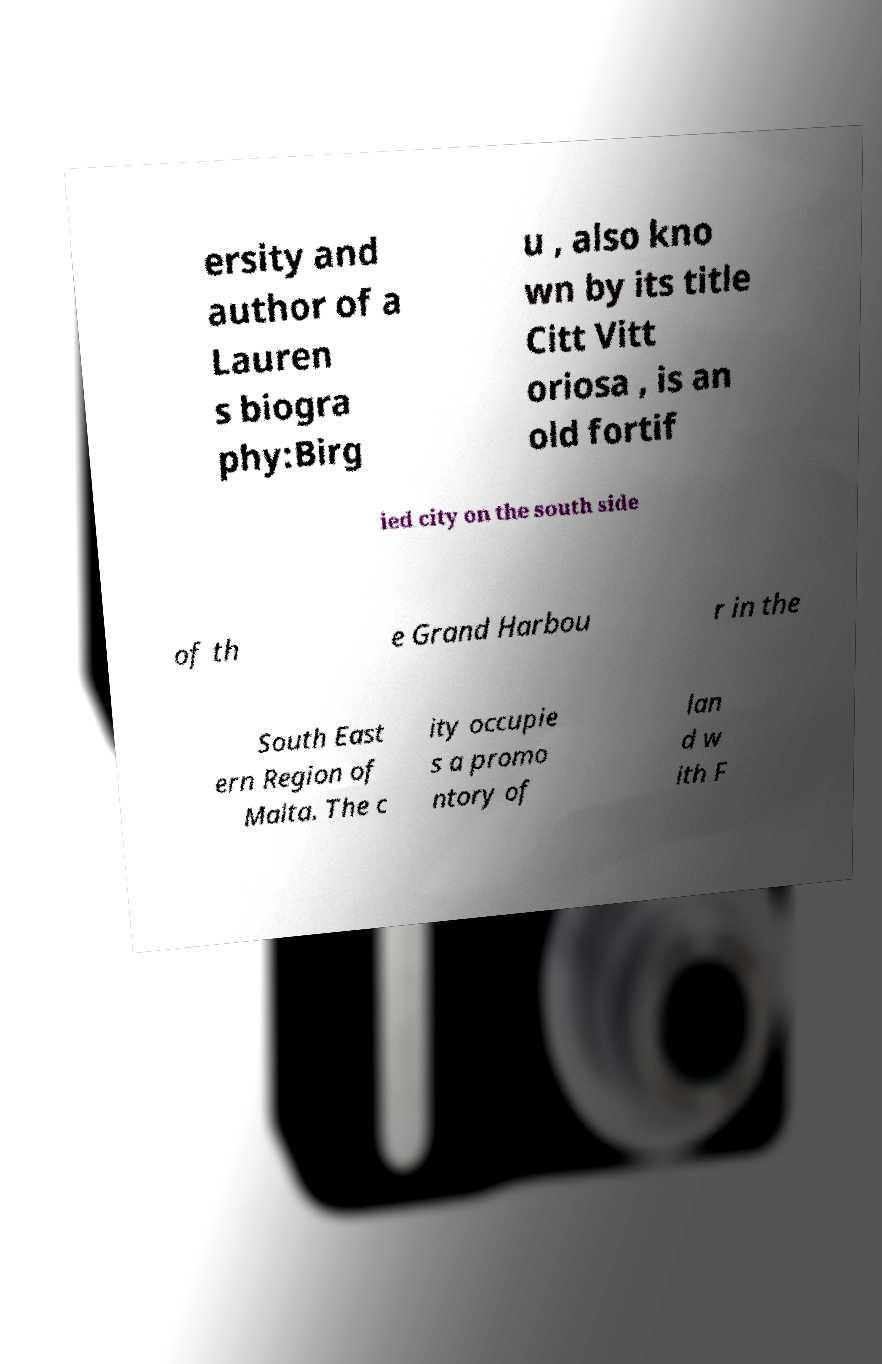There's text embedded in this image that I need extracted. Can you transcribe it verbatim? ersity and author of a Lauren s biogra phy:Birg u , also kno wn by its title Citt Vitt oriosa , is an old fortif ied city on the south side of th e Grand Harbou r in the South East ern Region of Malta. The c ity occupie s a promo ntory of lan d w ith F 